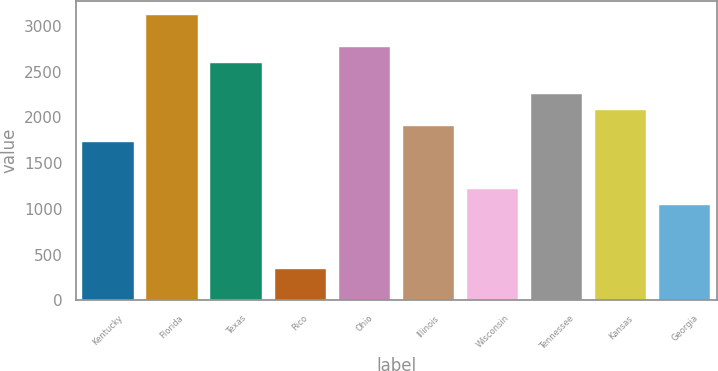Convert chart to OTSL. <chart><loc_0><loc_0><loc_500><loc_500><bar_chart><fcel>Kentucky<fcel>Florida<fcel>Texas<fcel>Rico<fcel>Ohio<fcel>Illinois<fcel>Wisconsin<fcel>Tennessee<fcel>Kansas<fcel>Georgia<nl><fcel>1733.81<fcel>3120.37<fcel>2600.41<fcel>347.25<fcel>2773.73<fcel>1907.13<fcel>1213.85<fcel>2253.77<fcel>2080.45<fcel>1040.53<nl></chart> 